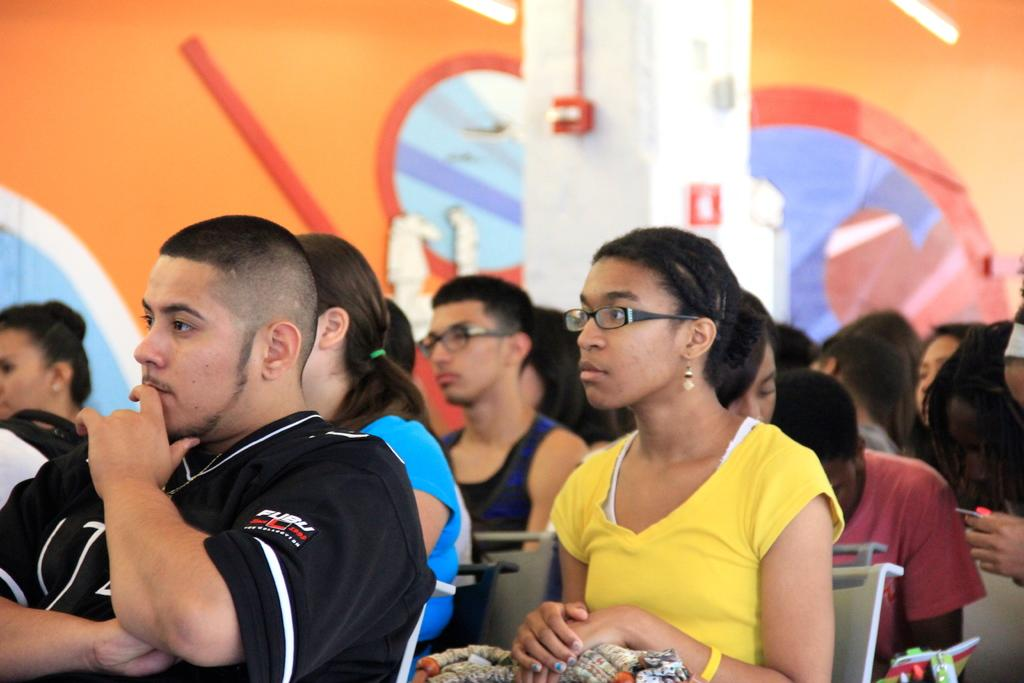Who or what can be seen in the image? There are people in the image. What are the people doing in the image? The people are sitting on chairs. What type of sorting is happening in the lunchroom during the party in the image? There is no mention of a lunchroom or a party in the image. The image only shows people sitting on chairs. 